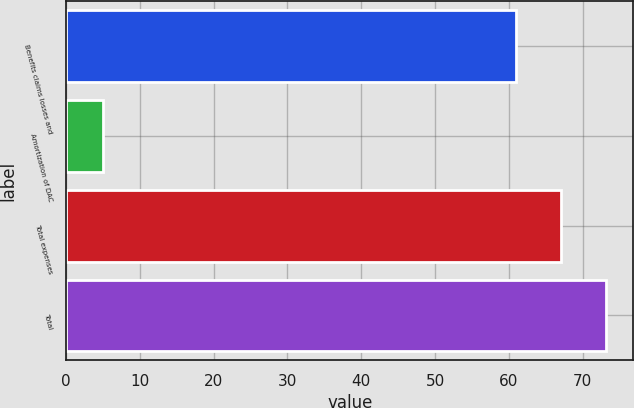<chart> <loc_0><loc_0><loc_500><loc_500><bar_chart><fcel>Benefits claims losses and<fcel>Amortization of DAC<fcel>Total expenses<fcel>Total<nl><fcel>61<fcel>5<fcel>67.1<fcel>73.2<nl></chart> 